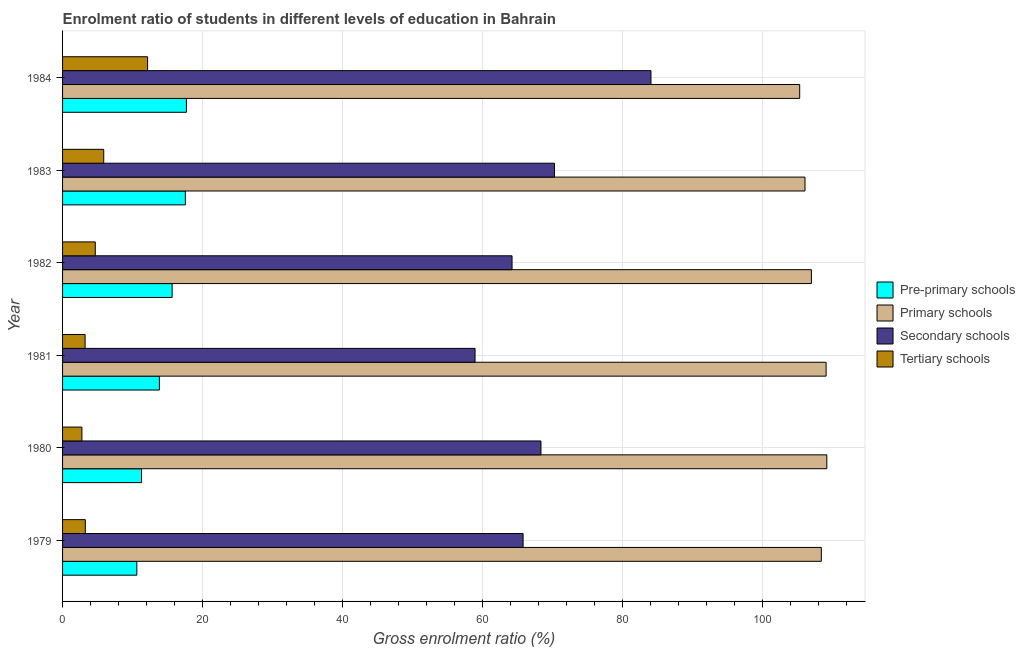How many groups of bars are there?
Your answer should be very brief. 6. Are the number of bars per tick equal to the number of legend labels?
Provide a succinct answer. Yes. How many bars are there on the 3rd tick from the bottom?
Provide a succinct answer. 4. What is the gross enrolment ratio in tertiary schools in 1979?
Provide a short and direct response. 3.25. Across all years, what is the maximum gross enrolment ratio in secondary schools?
Give a very brief answer. 84.11. Across all years, what is the minimum gross enrolment ratio in tertiary schools?
Your answer should be very brief. 2.76. What is the total gross enrolment ratio in pre-primary schools in the graph?
Offer a very short reply. 86.67. What is the difference between the gross enrolment ratio in tertiary schools in 1979 and that in 1982?
Make the answer very short. -1.43. What is the difference between the gross enrolment ratio in tertiary schools in 1984 and the gross enrolment ratio in secondary schools in 1979?
Your answer should be compact. -53.68. What is the average gross enrolment ratio in tertiary schools per year?
Ensure brevity in your answer.  5.33. In the year 1982, what is the difference between the gross enrolment ratio in primary schools and gross enrolment ratio in pre-primary schools?
Provide a succinct answer. 91.38. In how many years, is the gross enrolment ratio in primary schools greater than 84 %?
Offer a terse response. 6. What is the ratio of the gross enrolment ratio in secondary schools in 1983 to that in 1984?
Give a very brief answer. 0.84. What is the difference between the highest and the second highest gross enrolment ratio in secondary schools?
Keep it short and to the point. 13.8. What is the difference between the highest and the lowest gross enrolment ratio in secondary schools?
Provide a succinct answer. 25.15. In how many years, is the gross enrolment ratio in primary schools greater than the average gross enrolment ratio in primary schools taken over all years?
Make the answer very short. 3. Is it the case that in every year, the sum of the gross enrolment ratio in tertiary schools and gross enrolment ratio in primary schools is greater than the sum of gross enrolment ratio in pre-primary schools and gross enrolment ratio in secondary schools?
Ensure brevity in your answer.  No. What does the 2nd bar from the top in 1979 represents?
Provide a short and direct response. Secondary schools. What does the 1st bar from the bottom in 1979 represents?
Keep it short and to the point. Pre-primary schools. How many bars are there?
Your answer should be very brief. 24. How many years are there in the graph?
Make the answer very short. 6. What is the difference between two consecutive major ticks on the X-axis?
Your response must be concise. 20. Does the graph contain any zero values?
Give a very brief answer. No. Does the graph contain grids?
Make the answer very short. Yes. Where does the legend appear in the graph?
Your answer should be compact. Center right. How are the legend labels stacked?
Provide a succinct answer. Vertical. What is the title of the graph?
Your response must be concise. Enrolment ratio of students in different levels of education in Bahrain. Does "Salary of employees" appear as one of the legend labels in the graph?
Provide a succinct answer. No. What is the label or title of the Y-axis?
Your answer should be very brief. Year. What is the Gross enrolment ratio (%) in Pre-primary schools in 1979?
Provide a succinct answer. 10.62. What is the Gross enrolment ratio (%) of Primary schools in 1979?
Your response must be concise. 108.46. What is the Gross enrolment ratio (%) of Secondary schools in 1979?
Keep it short and to the point. 65.83. What is the Gross enrolment ratio (%) of Tertiary schools in 1979?
Give a very brief answer. 3.25. What is the Gross enrolment ratio (%) in Pre-primary schools in 1980?
Ensure brevity in your answer.  11.29. What is the Gross enrolment ratio (%) in Primary schools in 1980?
Provide a short and direct response. 109.25. What is the Gross enrolment ratio (%) of Secondary schools in 1980?
Your answer should be compact. 68.39. What is the Gross enrolment ratio (%) of Tertiary schools in 1980?
Provide a succinct answer. 2.76. What is the Gross enrolment ratio (%) in Pre-primary schools in 1981?
Provide a short and direct response. 13.84. What is the Gross enrolment ratio (%) in Primary schools in 1981?
Provide a short and direct response. 109.15. What is the Gross enrolment ratio (%) of Secondary schools in 1981?
Ensure brevity in your answer.  58.96. What is the Gross enrolment ratio (%) in Tertiary schools in 1981?
Your answer should be very brief. 3.22. What is the Gross enrolment ratio (%) of Pre-primary schools in 1982?
Offer a terse response. 15.66. What is the Gross enrolment ratio (%) of Primary schools in 1982?
Keep it short and to the point. 107.04. What is the Gross enrolment ratio (%) of Secondary schools in 1982?
Make the answer very short. 64.25. What is the Gross enrolment ratio (%) of Tertiary schools in 1982?
Offer a very short reply. 4.68. What is the Gross enrolment ratio (%) of Pre-primary schools in 1983?
Provide a succinct answer. 17.55. What is the Gross enrolment ratio (%) in Primary schools in 1983?
Provide a short and direct response. 106.13. What is the Gross enrolment ratio (%) of Secondary schools in 1983?
Offer a terse response. 70.31. What is the Gross enrolment ratio (%) of Tertiary schools in 1983?
Offer a very short reply. 5.88. What is the Gross enrolment ratio (%) in Pre-primary schools in 1984?
Your answer should be very brief. 17.7. What is the Gross enrolment ratio (%) of Primary schools in 1984?
Offer a very short reply. 105.37. What is the Gross enrolment ratio (%) of Secondary schools in 1984?
Give a very brief answer. 84.11. What is the Gross enrolment ratio (%) of Tertiary schools in 1984?
Provide a succinct answer. 12.15. Across all years, what is the maximum Gross enrolment ratio (%) of Pre-primary schools?
Your answer should be compact. 17.7. Across all years, what is the maximum Gross enrolment ratio (%) in Primary schools?
Provide a succinct answer. 109.25. Across all years, what is the maximum Gross enrolment ratio (%) in Secondary schools?
Keep it short and to the point. 84.11. Across all years, what is the maximum Gross enrolment ratio (%) of Tertiary schools?
Your answer should be very brief. 12.15. Across all years, what is the minimum Gross enrolment ratio (%) of Pre-primary schools?
Give a very brief answer. 10.62. Across all years, what is the minimum Gross enrolment ratio (%) of Primary schools?
Your answer should be very brief. 105.37. Across all years, what is the minimum Gross enrolment ratio (%) in Secondary schools?
Keep it short and to the point. 58.96. Across all years, what is the minimum Gross enrolment ratio (%) of Tertiary schools?
Your answer should be compact. 2.76. What is the total Gross enrolment ratio (%) of Pre-primary schools in the graph?
Provide a short and direct response. 86.67. What is the total Gross enrolment ratio (%) of Primary schools in the graph?
Keep it short and to the point. 645.4. What is the total Gross enrolment ratio (%) of Secondary schools in the graph?
Provide a succinct answer. 411.86. What is the total Gross enrolment ratio (%) in Tertiary schools in the graph?
Keep it short and to the point. 31.95. What is the difference between the Gross enrolment ratio (%) in Pre-primary schools in 1979 and that in 1980?
Provide a short and direct response. -0.67. What is the difference between the Gross enrolment ratio (%) in Primary schools in 1979 and that in 1980?
Ensure brevity in your answer.  -0.78. What is the difference between the Gross enrolment ratio (%) in Secondary schools in 1979 and that in 1980?
Keep it short and to the point. -2.56. What is the difference between the Gross enrolment ratio (%) in Tertiary schools in 1979 and that in 1980?
Keep it short and to the point. 0.49. What is the difference between the Gross enrolment ratio (%) of Pre-primary schools in 1979 and that in 1981?
Your answer should be compact. -3.22. What is the difference between the Gross enrolment ratio (%) of Primary schools in 1979 and that in 1981?
Give a very brief answer. -0.68. What is the difference between the Gross enrolment ratio (%) of Secondary schools in 1979 and that in 1981?
Offer a terse response. 6.87. What is the difference between the Gross enrolment ratio (%) of Tertiary schools in 1979 and that in 1981?
Make the answer very short. 0.03. What is the difference between the Gross enrolment ratio (%) in Pre-primary schools in 1979 and that in 1982?
Make the answer very short. -5.04. What is the difference between the Gross enrolment ratio (%) in Primary schools in 1979 and that in 1982?
Your response must be concise. 1.42. What is the difference between the Gross enrolment ratio (%) in Secondary schools in 1979 and that in 1982?
Provide a succinct answer. 1.58. What is the difference between the Gross enrolment ratio (%) in Tertiary schools in 1979 and that in 1982?
Ensure brevity in your answer.  -1.43. What is the difference between the Gross enrolment ratio (%) in Pre-primary schools in 1979 and that in 1983?
Provide a short and direct response. -6.93. What is the difference between the Gross enrolment ratio (%) of Primary schools in 1979 and that in 1983?
Give a very brief answer. 2.33. What is the difference between the Gross enrolment ratio (%) of Secondary schools in 1979 and that in 1983?
Give a very brief answer. -4.48. What is the difference between the Gross enrolment ratio (%) in Tertiary schools in 1979 and that in 1983?
Ensure brevity in your answer.  -2.63. What is the difference between the Gross enrolment ratio (%) of Pre-primary schools in 1979 and that in 1984?
Ensure brevity in your answer.  -7.09. What is the difference between the Gross enrolment ratio (%) in Primary schools in 1979 and that in 1984?
Offer a terse response. 3.09. What is the difference between the Gross enrolment ratio (%) of Secondary schools in 1979 and that in 1984?
Offer a very short reply. -18.28. What is the difference between the Gross enrolment ratio (%) of Tertiary schools in 1979 and that in 1984?
Offer a very short reply. -8.9. What is the difference between the Gross enrolment ratio (%) in Pre-primary schools in 1980 and that in 1981?
Offer a terse response. -2.55. What is the difference between the Gross enrolment ratio (%) of Primary schools in 1980 and that in 1981?
Keep it short and to the point. 0.1. What is the difference between the Gross enrolment ratio (%) of Secondary schools in 1980 and that in 1981?
Provide a succinct answer. 9.42. What is the difference between the Gross enrolment ratio (%) of Tertiary schools in 1980 and that in 1981?
Offer a very short reply. -0.46. What is the difference between the Gross enrolment ratio (%) of Pre-primary schools in 1980 and that in 1982?
Your answer should be compact. -4.37. What is the difference between the Gross enrolment ratio (%) in Primary schools in 1980 and that in 1982?
Make the answer very short. 2.2. What is the difference between the Gross enrolment ratio (%) in Secondary schools in 1980 and that in 1982?
Provide a succinct answer. 4.13. What is the difference between the Gross enrolment ratio (%) in Tertiary schools in 1980 and that in 1982?
Your answer should be compact. -1.91. What is the difference between the Gross enrolment ratio (%) of Pre-primary schools in 1980 and that in 1983?
Provide a succinct answer. -6.26. What is the difference between the Gross enrolment ratio (%) of Primary schools in 1980 and that in 1983?
Give a very brief answer. 3.12. What is the difference between the Gross enrolment ratio (%) in Secondary schools in 1980 and that in 1983?
Offer a very short reply. -1.93. What is the difference between the Gross enrolment ratio (%) of Tertiary schools in 1980 and that in 1983?
Your answer should be compact. -3.12. What is the difference between the Gross enrolment ratio (%) of Pre-primary schools in 1980 and that in 1984?
Offer a terse response. -6.41. What is the difference between the Gross enrolment ratio (%) in Primary schools in 1980 and that in 1984?
Provide a succinct answer. 3.88. What is the difference between the Gross enrolment ratio (%) of Secondary schools in 1980 and that in 1984?
Give a very brief answer. -15.72. What is the difference between the Gross enrolment ratio (%) of Tertiary schools in 1980 and that in 1984?
Provide a short and direct response. -9.39. What is the difference between the Gross enrolment ratio (%) of Pre-primary schools in 1981 and that in 1982?
Provide a short and direct response. -1.82. What is the difference between the Gross enrolment ratio (%) in Primary schools in 1981 and that in 1982?
Offer a very short reply. 2.1. What is the difference between the Gross enrolment ratio (%) in Secondary schools in 1981 and that in 1982?
Your response must be concise. -5.29. What is the difference between the Gross enrolment ratio (%) in Tertiary schools in 1981 and that in 1982?
Your response must be concise. -1.45. What is the difference between the Gross enrolment ratio (%) of Pre-primary schools in 1981 and that in 1983?
Offer a terse response. -3.71. What is the difference between the Gross enrolment ratio (%) in Primary schools in 1981 and that in 1983?
Keep it short and to the point. 3.02. What is the difference between the Gross enrolment ratio (%) of Secondary schools in 1981 and that in 1983?
Keep it short and to the point. -11.35. What is the difference between the Gross enrolment ratio (%) in Tertiary schools in 1981 and that in 1983?
Your answer should be very brief. -2.66. What is the difference between the Gross enrolment ratio (%) of Pre-primary schools in 1981 and that in 1984?
Offer a very short reply. -3.87. What is the difference between the Gross enrolment ratio (%) in Primary schools in 1981 and that in 1984?
Your answer should be compact. 3.78. What is the difference between the Gross enrolment ratio (%) of Secondary schools in 1981 and that in 1984?
Your answer should be compact. -25.15. What is the difference between the Gross enrolment ratio (%) of Tertiary schools in 1981 and that in 1984?
Provide a short and direct response. -8.93. What is the difference between the Gross enrolment ratio (%) in Pre-primary schools in 1982 and that in 1983?
Provide a short and direct response. -1.89. What is the difference between the Gross enrolment ratio (%) of Primary schools in 1982 and that in 1983?
Make the answer very short. 0.91. What is the difference between the Gross enrolment ratio (%) in Secondary schools in 1982 and that in 1983?
Provide a short and direct response. -6.06. What is the difference between the Gross enrolment ratio (%) in Tertiary schools in 1982 and that in 1983?
Offer a very short reply. -1.21. What is the difference between the Gross enrolment ratio (%) in Pre-primary schools in 1982 and that in 1984?
Your answer should be compact. -2.04. What is the difference between the Gross enrolment ratio (%) in Primary schools in 1982 and that in 1984?
Ensure brevity in your answer.  1.67. What is the difference between the Gross enrolment ratio (%) in Secondary schools in 1982 and that in 1984?
Your response must be concise. -19.86. What is the difference between the Gross enrolment ratio (%) in Tertiary schools in 1982 and that in 1984?
Keep it short and to the point. -7.48. What is the difference between the Gross enrolment ratio (%) of Pre-primary schools in 1983 and that in 1984?
Provide a succinct answer. -0.15. What is the difference between the Gross enrolment ratio (%) in Primary schools in 1983 and that in 1984?
Offer a terse response. 0.76. What is the difference between the Gross enrolment ratio (%) in Secondary schools in 1983 and that in 1984?
Keep it short and to the point. -13.8. What is the difference between the Gross enrolment ratio (%) in Tertiary schools in 1983 and that in 1984?
Make the answer very short. -6.27. What is the difference between the Gross enrolment ratio (%) of Pre-primary schools in 1979 and the Gross enrolment ratio (%) of Primary schools in 1980?
Provide a short and direct response. -98.63. What is the difference between the Gross enrolment ratio (%) of Pre-primary schools in 1979 and the Gross enrolment ratio (%) of Secondary schools in 1980?
Offer a terse response. -57.77. What is the difference between the Gross enrolment ratio (%) in Pre-primary schools in 1979 and the Gross enrolment ratio (%) in Tertiary schools in 1980?
Provide a succinct answer. 7.85. What is the difference between the Gross enrolment ratio (%) of Primary schools in 1979 and the Gross enrolment ratio (%) of Secondary schools in 1980?
Give a very brief answer. 40.08. What is the difference between the Gross enrolment ratio (%) of Primary schools in 1979 and the Gross enrolment ratio (%) of Tertiary schools in 1980?
Make the answer very short. 105.7. What is the difference between the Gross enrolment ratio (%) in Secondary schools in 1979 and the Gross enrolment ratio (%) in Tertiary schools in 1980?
Make the answer very short. 63.07. What is the difference between the Gross enrolment ratio (%) of Pre-primary schools in 1979 and the Gross enrolment ratio (%) of Primary schools in 1981?
Keep it short and to the point. -98.53. What is the difference between the Gross enrolment ratio (%) of Pre-primary schools in 1979 and the Gross enrolment ratio (%) of Secondary schools in 1981?
Provide a succinct answer. -48.34. What is the difference between the Gross enrolment ratio (%) of Pre-primary schools in 1979 and the Gross enrolment ratio (%) of Tertiary schools in 1981?
Provide a succinct answer. 7.4. What is the difference between the Gross enrolment ratio (%) in Primary schools in 1979 and the Gross enrolment ratio (%) in Secondary schools in 1981?
Your answer should be compact. 49.5. What is the difference between the Gross enrolment ratio (%) of Primary schools in 1979 and the Gross enrolment ratio (%) of Tertiary schools in 1981?
Give a very brief answer. 105.24. What is the difference between the Gross enrolment ratio (%) in Secondary schools in 1979 and the Gross enrolment ratio (%) in Tertiary schools in 1981?
Offer a terse response. 62.61. What is the difference between the Gross enrolment ratio (%) of Pre-primary schools in 1979 and the Gross enrolment ratio (%) of Primary schools in 1982?
Offer a very short reply. -96.42. What is the difference between the Gross enrolment ratio (%) of Pre-primary schools in 1979 and the Gross enrolment ratio (%) of Secondary schools in 1982?
Offer a terse response. -53.63. What is the difference between the Gross enrolment ratio (%) of Pre-primary schools in 1979 and the Gross enrolment ratio (%) of Tertiary schools in 1982?
Keep it short and to the point. 5.94. What is the difference between the Gross enrolment ratio (%) of Primary schools in 1979 and the Gross enrolment ratio (%) of Secondary schools in 1982?
Give a very brief answer. 44.21. What is the difference between the Gross enrolment ratio (%) of Primary schools in 1979 and the Gross enrolment ratio (%) of Tertiary schools in 1982?
Your answer should be compact. 103.79. What is the difference between the Gross enrolment ratio (%) of Secondary schools in 1979 and the Gross enrolment ratio (%) of Tertiary schools in 1982?
Your answer should be very brief. 61.15. What is the difference between the Gross enrolment ratio (%) in Pre-primary schools in 1979 and the Gross enrolment ratio (%) in Primary schools in 1983?
Your response must be concise. -95.51. What is the difference between the Gross enrolment ratio (%) in Pre-primary schools in 1979 and the Gross enrolment ratio (%) in Secondary schools in 1983?
Provide a succinct answer. -59.7. What is the difference between the Gross enrolment ratio (%) of Pre-primary schools in 1979 and the Gross enrolment ratio (%) of Tertiary schools in 1983?
Provide a succinct answer. 4.73. What is the difference between the Gross enrolment ratio (%) in Primary schools in 1979 and the Gross enrolment ratio (%) in Secondary schools in 1983?
Your answer should be compact. 38.15. What is the difference between the Gross enrolment ratio (%) of Primary schools in 1979 and the Gross enrolment ratio (%) of Tertiary schools in 1983?
Provide a succinct answer. 102.58. What is the difference between the Gross enrolment ratio (%) of Secondary schools in 1979 and the Gross enrolment ratio (%) of Tertiary schools in 1983?
Keep it short and to the point. 59.95. What is the difference between the Gross enrolment ratio (%) of Pre-primary schools in 1979 and the Gross enrolment ratio (%) of Primary schools in 1984?
Ensure brevity in your answer.  -94.75. What is the difference between the Gross enrolment ratio (%) of Pre-primary schools in 1979 and the Gross enrolment ratio (%) of Secondary schools in 1984?
Give a very brief answer. -73.49. What is the difference between the Gross enrolment ratio (%) of Pre-primary schools in 1979 and the Gross enrolment ratio (%) of Tertiary schools in 1984?
Keep it short and to the point. -1.54. What is the difference between the Gross enrolment ratio (%) of Primary schools in 1979 and the Gross enrolment ratio (%) of Secondary schools in 1984?
Give a very brief answer. 24.35. What is the difference between the Gross enrolment ratio (%) of Primary schools in 1979 and the Gross enrolment ratio (%) of Tertiary schools in 1984?
Keep it short and to the point. 96.31. What is the difference between the Gross enrolment ratio (%) in Secondary schools in 1979 and the Gross enrolment ratio (%) in Tertiary schools in 1984?
Keep it short and to the point. 53.68. What is the difference between the Gross enrolment ratio (%) of Pre-primary schools in 1980 and the Gross enrolment ratio (%) of Primary schools in 1981?
Your response must be concise. -97.85. What is the difference between the Gross enrolment ratio (%) in Pre-primary schools in 1980 and the Gross enrolment ratio (%) in Secondary schools in 1981?
Your answer should be very brief. -47.67. What is the difference between the Gross enrolment ratio (%) of Pre-primary schools in 1980 and the Gross enrolment ratio (%) of Tertiary schools in 1981?
Provide a succinct answer. 8.07. What is the difference between the Gross enrolment ratio (%) of Primary schools in 1980 and the Gross enrolment ratio (%) of Secondary schools in 1981?
Offer a very short reply. 50.28. What is the difference between the Gross enrolment ratio (%) in Primary schools in 1980 and the Gross enrolment ratio (%) in Tertiary schools in 1981?
Offer a terse response. 106.02. What is the difference between the Gross enrolment ratio (%) of Secondary schools in 1980 and the Gross enrolment ratio (%) of Tertiary schools in 1981?
Your response must be concise. 65.16. What is the difference between the Gross enrolment ratio (%) of Pre-primary schools in 1980 and the Gross enrolment ratio (%) of Primary schools in 1982?
Offer a terse response. -95.75. What is the difference between the Gross enrolment ratio (%) in Pre-primary schools in 1980 and the Gross enrolment ratio (%) in Secondary schools in 1982?
Your answer should be very brief. -52.96. What is the difference between the Gross enrolment ratio (%) of Pre-primary schools in 1980 and the Gross enrolment ratio (%) of Tertiary schools in 1982?
Your response must be concise. 6.62. What is the difference between the Gross enrolment ratio (%) in Primary schools in 1980 and the Gross enrolment ratio (%) in Secondary schools in 1982?
Your response must be concise. 44.99. What is the difference between the Gross enrolment ratio (%) in Primary schools in 1980 and the Gross enrolment ratio (%) in Tertiary schools in 1982?
Give a very brief answer. 104.57. What is the difference between the Gross enrolment ratio (%) in Secondary schools in 1980 and the Gross enrolment ratio (%) in Tertiary schools in 1982?
Give a very brief answer. 63.71. What is the difference between the Gross enrolment ratio (%) in Pre-primary schools in 1980 and the Gross enrolment ratio (%) in Primary schools in 1983?
Your answer should be compact. -94.84. What is the difference between the Gross enrolment ratio (%) in Pre-primary schools in 1980 and the Gross enrolment ratio (%) in Secondary schools in 1983?
Keep it short and to the point. -59.02. What is the difference between the Gross enrolment ratio (%) in Pre-primary schools in 1980 and the Gross enrolment ratio (%) in Tertiary schools in 1983?
Offer a very short reply. 5.41. What is the difference between the Gross enrolment ratio (%) of Primary schools in 1980 and the Gross enrolment ratio (%) of Secondary schools in 1983?
Your response must be concise. 38.93. What is the difference between the Gross enrolment ratio (%) of Primary schools in 1980 and the Gross enrolment ratio (%) of Tertiary schools in 1983?
Make the answer very short. 103.36. What is the difference between the Gross enrolment ratio (%) in Secondary schools in 1980 and the Gross enrolment ratio (%) in Tertiary schools in 1983?
Keep it short and to the point. 62.5. What is the difference between the Gross enrolment ratio (%) in Pre-primary schools in 1980 and the Gross enrolment ratio (%) in Primary schools in 1984?
Your answer should be very brief. -94.08. What is the difference between the Gross enrolment ratio (%) of Pre-primary schools in 1980 and the Gross enrolment ratio (%) of Secondary schools in 1984?
Your answer should be very brief. -72.82. What is the difference between the Gross enrolment ratio (%) of Pre-primary schools in 1980 and the Gross enrolment ratio (%) of Tertiary schools in 1984?
Offer a terse response. -0.86. What is the difference between the Gross enrolment ratio (%) in Primary schools in 1980 and the Gross enrolment ratio (%) in Secondary schools in 1984?
Keep it short and to the point. 25.14. What is the difference between the Gross enrolment ratio (%) of Primary schools in 1980 and the Gross enrolment ratio (%) of Tertiary schools in 1984?
Make the answer very short. 97.09. What is the difference between the Gross enrolment ratio (%) of Secondary schools in 1980 and the Gross enrolment ratio (%) of Tertiary schools in 1984?
Your answer should be very brief. 56.23. What is the difference between the Gross enrolment ratio (%) of Pre-primary schools in 1981 and the Gross enrolment ratio (%) of Primary schools in 1982?
Give a very brief answer. -93.2. What is the difference between the Gross enrolment ratio (%) in Pre-primary schools in 1981 and the Gross enrolment ratio (%) in Secondary schools in 1982?
Provide a short and direct response. -50.41. What is the difference between the Gross enrolment ratio (%) in Pre-primary schools in 1981 and the Gross enrolment ratio (%) in Tertiary schools in 1982?
Offer a terse response. 9.16. What is the difference between the Gross enrolment ratio (%) of Primary schools in 1981 and the Gross enrolment ratio (%) of Secondary schools in 1982?
Keep it short and to the point. 44.89. What is the difference between the Gross enrolment ratio (%) in Primary schools in 1981 and the Gross enrolment ratio (%) in Tertiary schools in 1982?
Your answer should be very brief. 104.47. What is the difference between the Gross enrolment ratio (%) in Secondary schools in 1981 and the Gross enrolment ratio (%) in Tertiary schools in 1982?
Offer a terse response. 54.28. What is the difference between the Gross enrolment ratio (%) in Pre-primary schools in 1981 and the Gross enrolment ratio (%) in Primary schools in 1983?
Ensure brevity in your answer.  -92.29. What is the difference between the Gross enrolment ratio (%) of Pre-primary schools in 1981 and the Gross enrolment ratio (%) of Secondary schools in 1983?
Offer a terse response. -56.48. What is the difference between the Gross enrolment ratio (%) of Pre-primary schools in 1981 and the Gross enrolment ratio (%) of Tertiary schools in 1983?
Give a very brief answer. 7.95. What is the difference between the Gross enrolment ratio (%) in Primary schools in 1981 and the Gross enrolment ratio (%) in Secondary schools in 1983?
Provide a succinct answer. 38.83. What is the difference between the Gross enrolment ratio (%) in Primary schools in 1981 and the Gross enrolment ratio (%) in Tertiary schools in 1983?
Make the answer very short. 103.26. What is the difference between the Gross enrolment ratio (%) of Secondary schools in 1981 and the Gross enrolment ratio (%) of Tertiary schools in 1983?
Make the answer very short. 53.08. What is the difference between the Gross enrolment ratio (%) of Pre-primary schools in 1981 and the Gross enrolment ratio (%) of Primary schools in 1984?
Your answer should be compact. -91.53. What is the difference between the Gross enrolment ratio (%) of Pre-primary schools in 1981 and the Gross enrolment ratio (%) of Secondary schools in 1984?
Offer a very short reply. -70.27. What is the difference between the Gross enrolment ratio (%) of Pre-primary schools in 1981 and the Gross enrolment ratio (%) of Tertiary schools in 1984?
Offer a very short reply. 1.69. What is the difference between the Gross enrolment ratio (%) in Primary schools in 1981 and the Gross enrolment ratio (%) in Secondary schools in 1984?
Your answer should be very brief. 25.04. What is the difference between the Gross enrolment ratio (%) of Primary schools in 1981 and the Gross enrolment ratio (%) of Tertiary schools in 1984?
Ensure brevity in your answer.  96.99. What is the difference between the Gross enrolment ratio (%) of Secondary schools in 1981 and the Gross enrolment ratio (%) of Tertiary schools in 1984?
Provide a short and direct response. 46.81. What is the difference between the Gross enrolment ratio (%) of Pre-primary schools in 1982 and the Gross enrolment ratio (%) of Primary schools in 1983?
Your answer should be compact. -90.47. What is the difference between the Gross enrolment ratio (%) in Pre-primary schools in 1982 and the Gross enrolment ratio (%) in Secondary schools in 1983?
Provide a short and direct response. -54.65. What is the difference between the Gross enrolment ratio (%) in Pre-primary schools in 1982 and the Gross enrolment ratio (%) in Tertiary schools in 1983?
Provide a short and direct response. 9.78. What is the difference between the Gross enrolment ratio (%) of Primary schools in 1982 and the Gross enrolment ratio (%) of Secondary schools in 1983?
Your answer should be compact. 36.73. What is the difference between the Gross enrolment ratio (%) in Primary schools in 1982 and the Gross enrolment ratio (%) in Tertiary schools in 1983?
Your answer should be very brief. 101.16. What is the difference between the Gross enrolment ratio (%) of Secondary schools in 1982 and the Gross enrolment ratio (%) of Tertiary schools in 1983?
Ensure brevity in your answer.  58.37. What is the difference between the Gross enrolment ratio (%) of Pre-primary schools in 1982 and the Gross enrolment ratio (%) of Primary schools in 1984?
Your answer should be very brief. -89.71. What is the difference between the Gross enrolment ratio (%) of Pre-primary schools in 1982 and the Gross enrolment ratio (%) of Secondary schools in 1984?
Provide a short and direct response. -68.45. What is the difference between the Gross enrolment ratio (%) in Pre-primary schools in 1982 and the Gross enrolment ratio (%) in Tertiary schools in 1984?
Provide a short and direct response. 3.51. What is the difference between the Gross enrolment ratio (%) of Primary schools in 1982 and the Gross enrolment ratio (%) of Secondary schools in 1984?
Offer a very short reply. 22.93. What is the difference between the Gross enrolment ratio (%) in Primary schools in 1982 and the Gross enrolment ratio (%) in Tertiary schools in 1984?
Your answer should be compact. 94.89. What is the difference between the Gross enrolment ratio (%) of Secondary schools in 1982 and the Gross enrolment ratio (%) of Tertiary schools in 1984?
Ensure brevity in your answer.  52.1. What is the difference between the Gross enrolment ratio (%) in Pre-primary schools in 1983 and the Gross enrolment ratio (%) in Primary schools in 1984?
Your response must be concise. -87.82. What is the difference between the Gross enrolment ratio (%) in Pre-primary schools in 1983 and the Gross enrolment ratio (%) in Secondary schools in 1984?
Keep it short and to the point. -66.56. What is the difference between the Gross enrolment ratio (%) of Pre-primary schools in 1983 and the Gross enrolment ratio (%) of Tertiary schools in 1984?
Your response must be concise. 5.4. What is the difference between the Gross enrolment ratio (%) of Primary schools in 1983 and the Gross enrolment ratio (%) of Secondary schools in 1984?
Your answer should be compact. 22.02. What is the difference between the Gross enrolment ratio (%) of Primary schools in 1983 and the Gross enrolment ratio (%) of Tertiary schools in 1984?
Keep it short and to the point. 93.98. What is the difference between the Gross enrolment ratio (%) of Secondary schools in 1983 and the Gross enrolment ratio (%) of Tertiary schools in 1984?
Offer a terse response. 58.16. What is the average Gross enrolment ratio (%) of Pre-primary schools per year?
Your answer should be very brief. 14.44. What is the average Gross enrolment ratio (%) of Primary schools per year?
Give a very brief answer. 107.57. What is the average Gross enrolment ratio (%) of Secondary schools per year?
Provide a succinct answer. 68.64. What is the average Gross enrolment ratio (%) of Tertiary schools per year?
Your answer should be very brief. 5.33. In the year 1979, what is the difference between the Gross enrolment ratio (%) of Pre-primary schools and Gross enrolment ratio (%) of Primary schools?
Ensure brevity in your answer.  -97.85. In the year 1979, what is the difference between the Gross enrolment ratio (%) of Pre-primary schools and Gross enrolment ratio (%) of Secondary schools?
Offer a terse response. -55.21. In the year 1979, what is the difference between the Gross enrolment ratio (%) of Pre-primary schools and Gross enrolment ratio (%) of Tertiary schools?
Ensure brevity in your answer.  7.37. In the year 1979, what is the difference between the Gross enrolment ratio (%) in Primary schools and Gross enrolment ratio (%) in Secondary schools?
Provide a succinct answer. 42.63. In the year 1979, what is the difference between the Gross enrolment ratio (%) of Primary schools and Gross enrolment ratio (%) of Tertiary schools?
Give a very brief answer. 105.21. In the year 1979, what is the difference between the Gross enrolment ratio (%) of Secondary schools and Gross enrolment ratio (%) of Tertiary schools?
Your response must be concise. 62.58. In the year 1980, what is the difference between the Gross enrolment ratio (%) of Pre-primary schools and Gross enrolment ratio (%) of Primary schools?
Keep it short and to the point. -97.95. In the year 1980, what is the difference between the Gross enrolment ratio (%) in Pre-primary schools and Gross enrolment ratio (%) in Secondary schools?
Give a very brief answer. -57.09. In the year 1980, what is the difference between the Gross enrolment ratio (%) of Pre-primary schools and Gross enrolment ratio (%) of Tertiary schools?
Your response must be concise. 8.53. In the year 1980, what is the difference between the Gross enrolment ratio (%) of Primary schools and Gross enrolment ratio (%) of Secondary schools?
Your answer should be compact. 40.86. In the year 1980, what is the difference between the Gross enrolment ratio (%) of Primary schools and Gross enrolment ratio (%) of Tertiary schools?
Provide a short and direct response. 106.48. In the year 1980, what is the difference between the Gross enrolment ratio (%) in Secondary schools and Gross enrolment ratio (%) in Tertiary schools?
Offer a very short reply. 65.62. In the year 1981, what is the difference between the Gross enrolment ratio (%) of Pre-primary schools and Gross enrolment ratio (%) of Primary schools?
Ensure brevity in your answer.  -95.31. In the year 1981, what is the difference between the Gross enrolment ratio (%) of Pre-primary schools and Gross enrolment ratio (%) of Secondary schools?
Make the answer very short. -45.12. In the year 1981, what is the difference between the Gross enrolment ratio (%) in Pre-primary schools and Gross enrolment ratio (%) in Tertiary schools?
Provide a succinct answer. 10.62. In the year 1981, what is the difference between the Gross enrolment ratio (%) of Primary schools and Gross enrolment ratio (%) of Secondary schools?
Give a very brief answer. 50.18. In the year 1981, what is the difference between the Gross enrolment ratio (%) of Primary schools and Gross enrolment ratio (%) of Tertiary schools?
Provide a short and direct response. 105.92. In the year 1981, what is the difference between the Gross enrolment ratio (%) of Secondary schools and Gross enrolment ratio (%) of Tertiary schools?
Offer a very short reply. 55.74. In the year 1982, what is the difference between the Gross enrolment ratio (%) in Pre-primary schools and Gross enrolment ratio (%) in Primary schools?
Ensure brevity in your answer.  -91.38. In the year 1982, what is the difference between the Gross enrolment ratio (%) in Pre-primary schools and Gross enrolment ratio (%) in Secondary schools?
Give a very brief answer. -48.59. In the year 1982, what is the difference between the Gross enrolment ratio (%) of Pre-primary schools and Gross enrolment ratio (%) of Tertiary schools?
Your answer should be very brief. 10.98. In the year 1982, what is the difference between the Gross enrolment ratio (%) of Primary schools and Gross enrolment ratio (%) of Secondary schools?
Ensure brevity in your answer.  42.79. In the year 1982, what is the difference between the Gross enrolment ratio (%) of Primary schools and Gross enrolment ratio (%) of Tertiary schools?
Your answer should be compact. 102.37. In the year 1982, what is the difference between the Gross enrolment ratio (%) of Secondary schools and Gross enrolment ratio (%) of Tertiary schools?
Give a very brief answer. 59.58. In the year 1983, what is the difference between the Gross enrolment ratio (%) of Pre-primary schools and Gross enrolment ratio (%) of Primary schools?
Offer a very short reply. -88.58. In the year 1983, what is the difference between the Gross enrolment ratio (%) of Pre-primary schools and Gross enrolment ratio (%) of Secondary schools?
Provide a short and direct response. -52.76. In the year 1983, what is the difference between the Gross enrolment ratio (%) of Pre-primary schools and Gross enrolment ratio (%) of Tertiary schools?
Your answer should be compact. 11.67. In the year 1983, what is the difference between the Gross enrolment ratio (%) of Primary schools and Gross enrolment ratio (%) of Secondary schools?
Ensure brevity in your answer.  35.81. In the year 1983, what is the difference between the Gross enrolment ratio (%) of Primary schools and Gross enrolment ratio (%) of Tertiary schools?
Your response must be concise. 100.24. In the year 1983, what is the difference between the Gross enrolment ratio (%) of Secondary schools and Gross enrolment ratio (%) of Tertiary schools?
Provide a short and direct response. 64.43. In the year 1984, what is the difference between the Gross enrolment ratio (%) in Pre-primary schools and Gross enrolment ratio (%) in Primary schools?
Your answer should be very brief. -87.67. In the year 1984, what is the difference between the Gross enrolment ratio (%) in Pre-primary schools and Gross enrolment ratio (%) in Secondary schools?
Offer a terse response. -66.41. In the year 1984, what is the difference between the Gross enrolment ratio (%) in Pre-primary schools and Gross enrolment ratio (%) in Tertiary schools?
Ensure brevity in your answer.  5.55. In the year 1984, what is the difference between the Gross enrolment ratio (%) of Primary schools and Gross enrolment ratio (%) of Secondary schools?
Keep it short and to the point. 21.26. In the year 1984, what is the difference between the Gross enrolment ratio (%) of Primary schools and Gross enrolment ratio (%) of Tertiary schools?
Offer a very short reply. 93.22. In the year 1984, what is the difference between the Gross enrolment ratio (%) of Secondary schools and Gross enrolment ratio (%) of Tertiary schools?
Your answer should be compact. 71.96. What is the ratio of the Gross enrolment ratio (%) of Pre-primary schools in 1979 to that in 1980?
Provide a short and direct response. 0.94. What is the ratio of the Gross enrolment ratio (%) in Secondary schools in 1979 to that in 1980?
Your answer should be very brief. 0.96. What is the ratio of the Gross enrolment ratio (%) of Tertiary schools in 1979 to that in 1980?
Your response must be concise. 1.18. What is the ratio of the Gross enrolment ratio (%) in Pre-primary schools in 1979 to that in 1981?
Give a very brief answer. 0.77. What is the ratio of the Gross enrolment ratio (%) of Secondary schools in 1979 to that in 1981?
Ensure brevity in your answer.  1.12. What is the ratio of the Gross enrolment ratio (%) of Tertiary schools in 1979 to that in 1981?
Offer a very short reply. 1.01. What is the ratio of the Gross enrolment ratio (%) in Pre-primary schools in 1979 to that in 1982?
Give a very brief answer. 0.68. What is the ratio of the Gross enrolment ratio (%) in Primary schools in 1979 to that in 1982?
Offer a very short reply. 1.01. What is the ratio of the Gross enrolment ratio (%) of Secondary schools in 1979 to that in 1982?
Offer a terse response. 1.02. What is the ratio of the Gross enrolment ratio (%) of Tertiary schools in 1979 to that in 1982?
Provide a short and direct response. 0.7. What is the ratio of the Gross enrolment ratio (%) in Pre-primary schools in 1979 to that in 1983?
Ensure brevity in your answer.  0.61. What is the ratio of the Gross enrolment ratio (%) in Secondary schools in 1979 to that in 1983?
Keep it short and to the point. 0.94. What is the ratio of the Gross enrolment ratio (%) of Tertiary schools in 1979 to that in 1983?
Offer a terse response. 0.55. What is the ratio of the Gross enrolment ratio (%) of Pre-primary schools in 1979 to that in 1984?
Offer a very short reply. 0.6. What is the ratio of the Gross enrolment ratio (%) in Primary schools in 1979 to that in 1984?
Ensure brevity in your answer.  1.03. What is the ratio of the Gross enrolment ratio (%) of Secondary schools in 1979 to that in 1984?
Your response must be concise. 0.78. What is the ratio of the Gross enrolment ratio (%) of Tertiary schools in 1979 to that in 1984?
Your response must be concise. 0.27. What is the ratio of the Gross enrolment ratio (%) in Pre-primary schools in 1980 to that in 1981?
Give a very brief answer. 0.82. What is the ratio of the Gross enrolment ratio (%) in Secondary schools in 1980 to that in 1981?
Offer a terse response. 1.16. What is the ratio of the Gross enrolment ratio (%) in Tertiary schools in 1980 to that in 1981?
Your answer should be compact. 0.86. What is the ratio of the Gross enrolment ratio (%) of Pre-primary schools in 1980 to that in 1982?
Provide a short and direct response. 0.72. What is the ratio of the Gross enrolment ratio (%) in Primary schools in 1980 to that in 1982?
Offer a terse response. 1.02. What is the ratio of the Gross enrolment ratio (%) of Secondary schools in 1980 to that in 1982?
Your response must be concise. 1.06. What is the ratio of the Gross enrolment ratio (%) in Tertiary schools in 1980 to that in 1982?
Keep it short and to the point. 0.59. What is the ratio of the Gross enrolment ratio (%) of Pre-primary schools in 1980 to that in 1983?
Your answer should be very brief. 0.64. What is the ratio of the Gross enrolment ratio (%) in Primary schools in 1980 to that in 1983?
Your answer should be very brief. 1.03. What is the ratio of the Gross enrolment ratio (%) in Secondary schools in 1980 to that in 1983?
Your answer should be compact. 0.97. What is the ratio of the Gross enrolment ratio (%) in Tertiary schools in 1980 to that in 1983?
Your answer should be compact. 0.47. What is the ratio of the Gross enrolment ratio (%) in Pre-primary schools in 1980 to that in 1984?
Make the answer very short. 0.64. What is the ratio of the Gross enrolment ratio (%) of Primary schools in 1980 to that in 1984?
Provide a succinct answer. 1.04. What is the ratio of the Gross enrolment ratio (%) of Secondary schools in 1980 to that in 1984?
Your answer should be very brief. 0.81. What is the ratio of the Gross enrolment ratio (%) of Tertiary schools in 1980 to that in 1984?
Your answer should be compact. 0.23. What is the ratio of the Gross enrolment ratio (%) in Pre-primary schools in 1981 to that in 1982?
Give a very brief answer. 0.88. What is the ratio of the Gross enrolment ratio (%) of Primary schools in 1981 to that in 1982?
Your response must be concise. 1.02. What is the ratio of the Gross enrolment ratio (%) of Secondary schools in 1981 to that in 1982?
Offer a very short reply. 0.92. What is the ratio of the Gross enrolment ratio (%) in Tertiary schools in 1981 to that in 1982?
Your answer should be compact. 0.69. What is the ratio of the Gross enrolment ratio (%) in Pre-primary schools in 1981 to that in 1983?
Provide a succinct answer. 0.79. What is the ratio of the Gross enrolment ratio (%) of Primary schools in 1981 to that in 1983?
Your answer should be very brief. 1.03. What is the ratio of the Gross enrolment ratio (%) in Secondary schools in 1981 to that in 1983?
Keep it short and to the point. 0.84. What is the ratio of the Gross enrolment ratio (%) of Tertiary schools in 1981 to that in 1983?
Your answer should be compact. 0.55. What is the ratio of the Gross enrolment ratio (%) of Pre-primary schools in 1981 to that in 1984?
Your response must be concise. 0.78. What is the ratio of the Gross enrolment ratio (%) in Primary schools in 1981 to that in 1984?
Provide a succinct answer. 1.04. What is the ratio of the Gross enrolment ratio (%) of Secondary schools in 1981 to that in 1984?
Provide a short and direct response. 0.7. What is the ratio of the Gross enrolment ratio (%) in Tertiary schools in 1981 to that in 1984?
Keep it short and to the point. 0.27. What is the ratio of the Gross enrolment ratio (%) in Pre-primary schools in 1982 to that in 1983?
Provide a short and direct response. 0.89. What is the ratio of the Gross enrolment ratio (%) in Primary schools in 1982 to that in 1983?
Provide a succinct answer. 1.01. What is the ratio of the Gross enrolment ratio (%) in Secondary schools in 1982 to that in 1983?
Your answer should be very brief. 0.91. What is the ratio of the Gross enrolment ratio (%) in Tertiary schools in 1982 to that in 1983?
Offer a terse response. 0.79. What is the ratio of the Gross enrolment ratio (%) of Pre-primary schools in 1982 to that in 1984?
Keep it short and to the point. 0.88. What is the ratio of the Gross enrolment ratio (%) of Primary schools in 1982 to that in 1984?
Offer a terse response. 1.02. What is the ratio of the Gross enrolment ratio (%) in Secondary schools in 1982 to that in 1984?
Your answer should be compact. 0.76. What is the ratio of the Gross enrolment ratio (%) in Tertiary schools in 1982 to that in 1984?
Give a very brief answer. 0.38. What is the ratio of the Gross enrolment ratio (%) of Pre-primary schools in 1983 to that in 1984?
Your response must be concise. 0.99. What is the ratio of the Gross enrolment ratio (%) of Secondary schools in 1983 to that in 1984?
Provide a short and direct response. 0.84. What is the ratio of the Gross enrolment ratio (%) of Tertiary schools in 1983 to that in 1984?
Make the answer very short. 0.48. What is the difference between the highest and the second highest Gross enrolment ratio (%) in Pre-primary schools?
Your answer should be compact. 0.15. What is the difference between the highest and the second highest Gross enrolment ratio (%) of Primary schools?
Provide a short and direct response. 0.1. What is the difference between the highest and the second highest Gross enrolment ratio (%) in Secondary schools?
Your response must be concise. 13.8. What is the difference between the highest and the second highest Gross enrolment ratio (%) in Tertiary schools?
Offer a very short reply. 6.27. What is the difference between the highest and the lowest Gross enrolment ratio (%) of Pre-primary schools?
Offer a very short reply. 7.09. What is the difference between the highest and the lowest Gross enrolment ratio (%) of Primary schools?
Offer a terse response. 3.88. What is the difference between the highest and the lowest Gross enrolment ratio (%) of Secondary schools?
Give a very brief answer. 25.15. What is the difference between the highest and the lowest Gross enrolment ratio (%) in Tertiary schools?
Give a very brief answer. 9.39. 